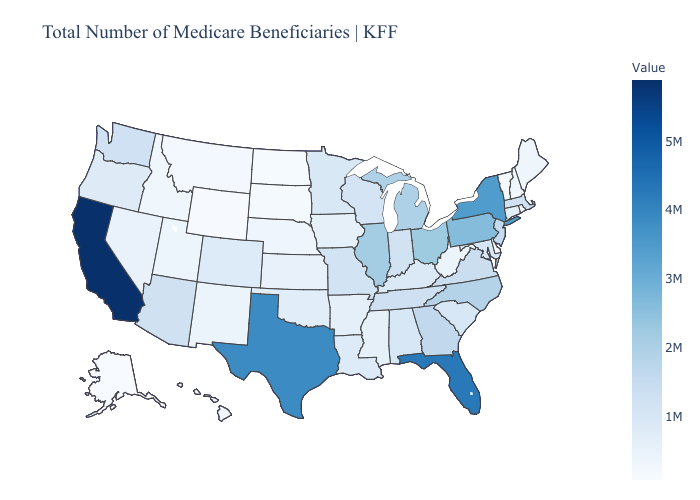Which states have the lowest value in the USA?
Short answer required. Alaska. Among the states that border Massachusetts , which have the lowest value?
Keep it brief. Vermont. Among the states that border Florida , does Alabama have the lowest value?
Keep it brief. Yes. Which states have the lowest value in the USA?
Give a very brief answer. Alaska. 